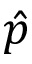<formula> <loc_0><loc_0><loc_500><loc_500>\hat { p }</formula> 